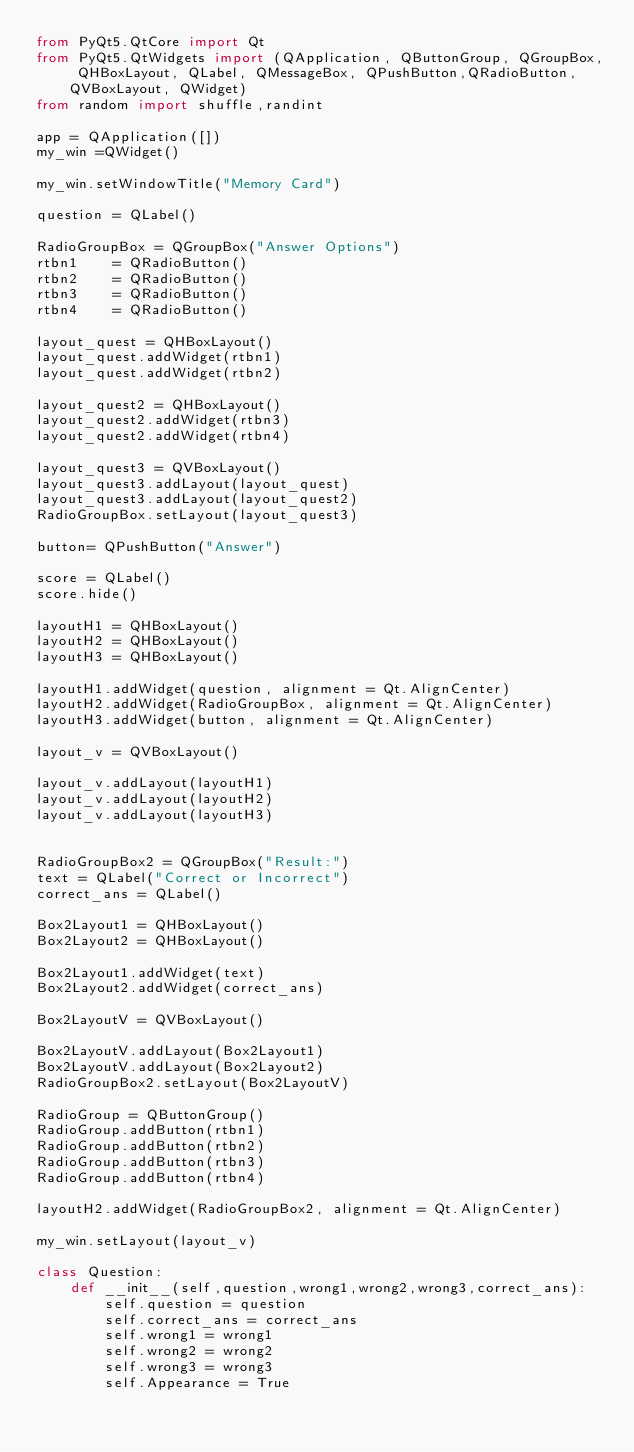<code> <loc_0><loc_0><loc_500><loc_500><_Python_>from PyQt5.QtCore import Qt
from PyQt5.QtWidgets import (QApplication, QButtonGroup, QGroupBox, QHBoxLayout, QLabel, QMessageBox, QPushButton,QRadioButton, QVBoxLayout, QWidget)
from random import shuffle,randint

app = QApplication([])
my_win =QWidget()

my_win.setWindowTitle("Memory Card")

question = QLabel()

RadioGroupBox = QGroupBox("Answer Options")
rtbn1    = QRadioButton()
rtbn2    = QRadioButton()
rtbn3    = QRadioButton()
rtbn4    = QRadioButton()

layout_quest = QHBoxLayout()
layout_quest.addWidget(rtbn1)
layout_quest.addWidget(rtbn2)

layout_quest2 = QHBoxLayout()
layout_quest2.addWidget(rtbn3)
layout_quest2.addWidget(rtbn4)

layout_quest3 = QVBoxLayout()
layout_quest3.addLayout(layout_quest)
layout_quest3.addLayout(layout_quest2)
RadioGroupBox.setLayout(layout_quest3)

button= QPushButton("Answer")

score = QLabel()
score.hide()

layoutH1 = QHBoxLayout()
layoutH2 = QHBoxLayout()
layoutH3 = QHBoxLayout()

layoutH1.addWidget(question, alignment = Qt.AlignCenter)
layoutH2.addWidget(RadioGroupBox, alignment = Qt.AlignCenter)
layoutH3.addWidget(button, alignment = Qt.AlignCenter)

layout_v = QVBoxLayout()

layout_v.addLayout(layoutH1)
layout_v.addLayout(layoutH2)
layout_v.addLayout(layoutH3)


RadioGroupBox2 = QGroupBox("Result:")
text = QLabel("Correct or Incorrect") 
correct_ans = QLabel() 

Box2Layout1 = QHBoxLayout()
Box2Layout2 = QHBoxLayout()

Box2Layout1.addWidget(text)
Box2Layout2.addWidget(correct_ans)

Box2LayoutV = QVBoxLayout()

Box2LayoutV.addLayout(Box2Layout1)
Box2LayoutV.addLayout(Box2Layout2)
RadioGroupBox2.setLayout(Box2LayoutV)
 
RadioGroup = QButtonGroup()
RadioGroup.addButton(rtbn1)
RadioGroup.addButton(rtbn2)
RadioGroup.addButton(rtbn3)
RadioGroup.addButton(rtbn4)

layoutH2.addWidget(RadioGroupBox2, alignment = Qt.AlignCenter)

my_win.setLayout(layout_v)

class Question:
    def __init__(self,question,wrong1,wrong2,wrong3,correct_ans):
        self.question = question
        self.correct_ans = correct_ans
        self.wrong1 = wrong1
        self.wrong2 = wrong2
        self.wrong3 = wrong3
        self.Appearance = True
</code> 